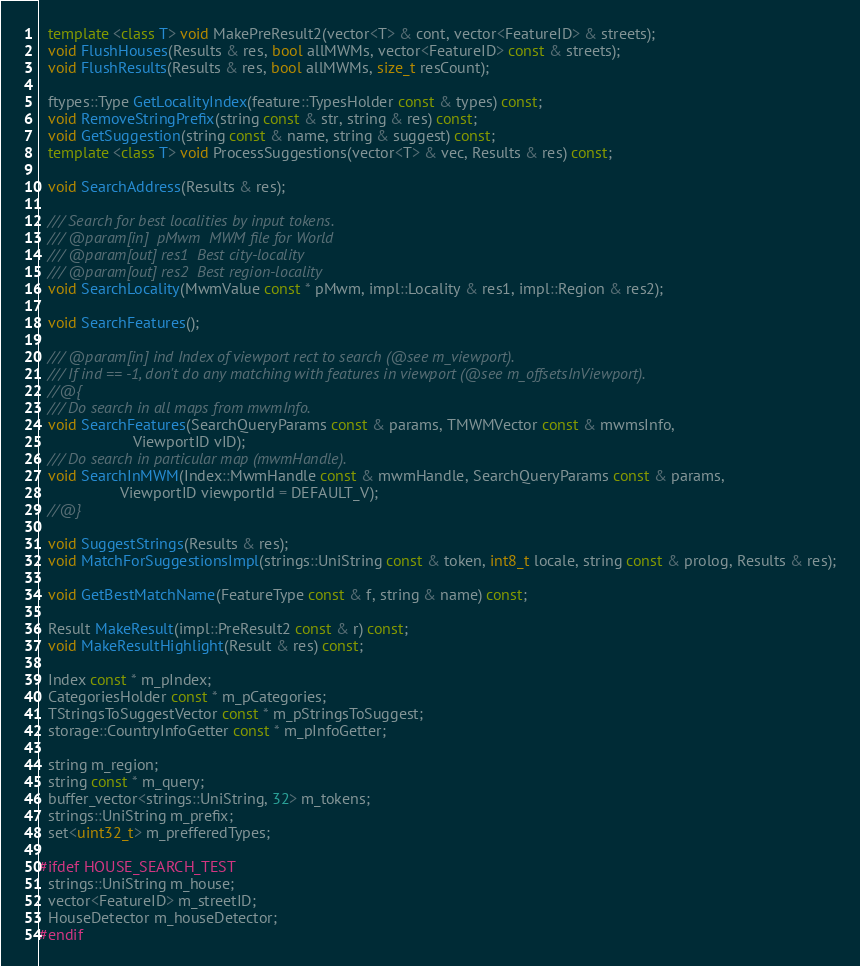<code> <loc_0><loc_0><loc_500><loc_500><_C++_>
  template <class T> void MakePreResult2(vector<T> & cont, vector<FeatureID> & streets);
  void FlushHouses(Results & res, bool allMWMs, vector<FeatureID> const & streets);
  void FlushResults(Results & res, bool allMWMs, size_t resCount);

  ftypes::Type GetLocalityIndex(feature::TypesHolder const & types) const;
  void RemoveStringPrefix(string const & str, string & res) const;
  void GetSuggestion(string const & name, string & suggest) const;
  template <class T> void ProcessSuggestions(vector<T> & vec, Results & res) const;

  void SearchAddress(Results & res);

  /// Search for best localities by input tokens.
  /// @param[in]  pMwm  MWM file for World
  /// @param[out] res1  Best city-locality
  /// @param[out] res2  Best region-locality
  void SearchLocality(MwmValue const * pMwm, impl::Locality & res1, impl::Region & res2);

  void SearchFeatures();

  /// @param[in] ind Index of viewport rect to search (@see m_viewport).
  /// If ind == -1, don't do any matching with features in viewport (@see m_offsetsInViewport).
  //@{
  /// Do search in all maps from mwmInfo.
  void SearchFeatures(SearchQueryParams const & params, TMWMVector const & mwmsInfo,
                      ViewportID vID);
  /// Do search in particular map (mwmHandle).
  void SearchInMWM(Index::MwmHandle const & mwmHandle, SearchQueryParams const & params,
                   ViewportID viewportId = DEFAULT_V);
  //@}

  void SuggestStrings(Results & res);
  void MatchForSuggestionsImpl(strings::UniString const & token, int8_t locale, string const & prolog, Results & res);

  void GetBestMatchName(FeatureType const & f, string & name) const;

  Result MakeResult(impl::PreResult2 const & r) const;
  void MakeResultHighlight(Result & res) const;

  Index const * m_pIndex;
  CategoriesHolder const * m_pCategories;
  TStringsToSuggestVector const * m_pStringsToSuggest;
  storage::CountryInfoGetter const * m_pInfoGetter;

  string m_region;
  string const * m_query;
  buffer_vector<strings::UniString, 32> m_tokens;
  strings::UniString m_prefix;
  set<uint32_t> m_prefferedTypes;

#ifdef HOUSE_SEARCH_TEST
  strings::UniString m_house;
  vector<FeatureID> m_streetID;
  HouseDetector m_houseDetector;
#endif
</code> 